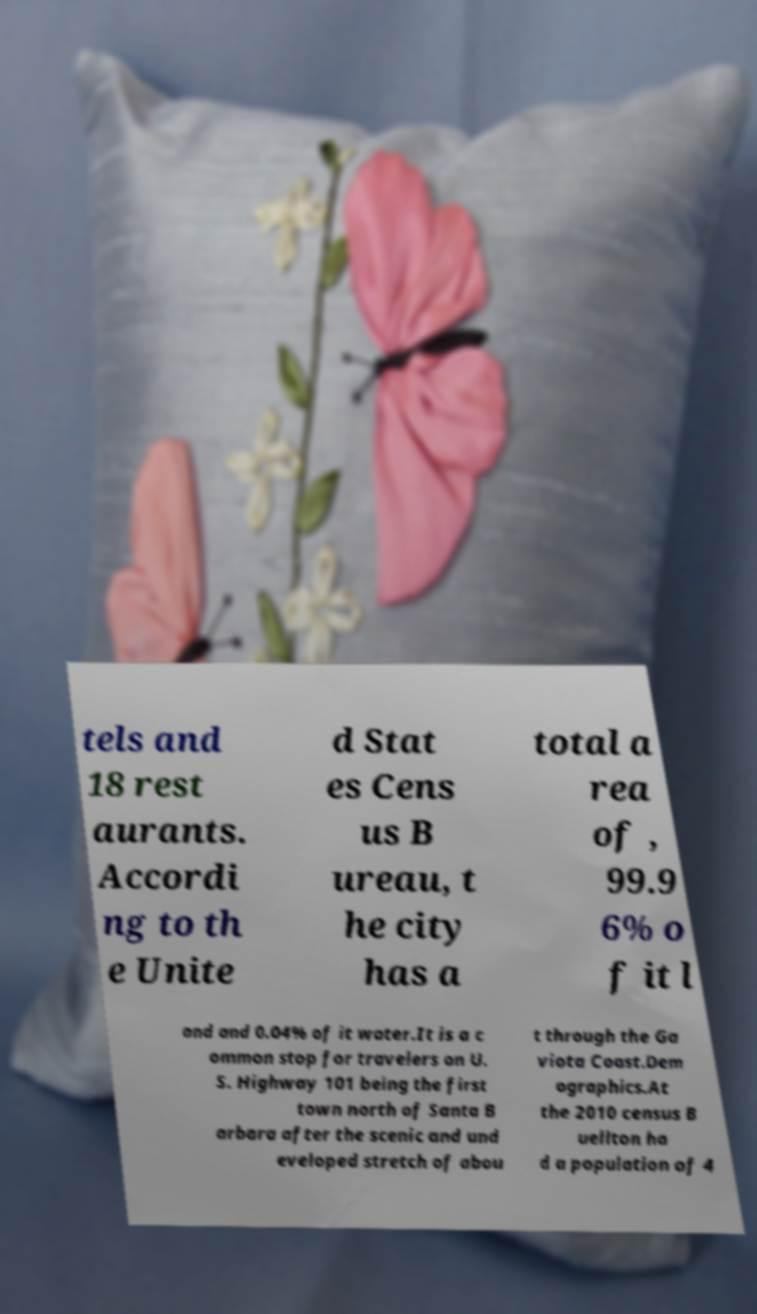There's text embedded in this image that I need extracted. Can you transcribe it verbatim? tels and 18 rest aurants. Accordi ng to th e Unite d Stat es Cens us B ureau, t he city has a total a rea of , 99.9 6% o f it l and and 0.04% of it water.It is a c ommon stop for travelers on U. S. Highway 101 being the first town north of Santa B arbara after the scenic and und eveloped stretch of abou t through the Ga viota Coast.Dem ographics.At the 2010 census B uellton ha d a population of 4 